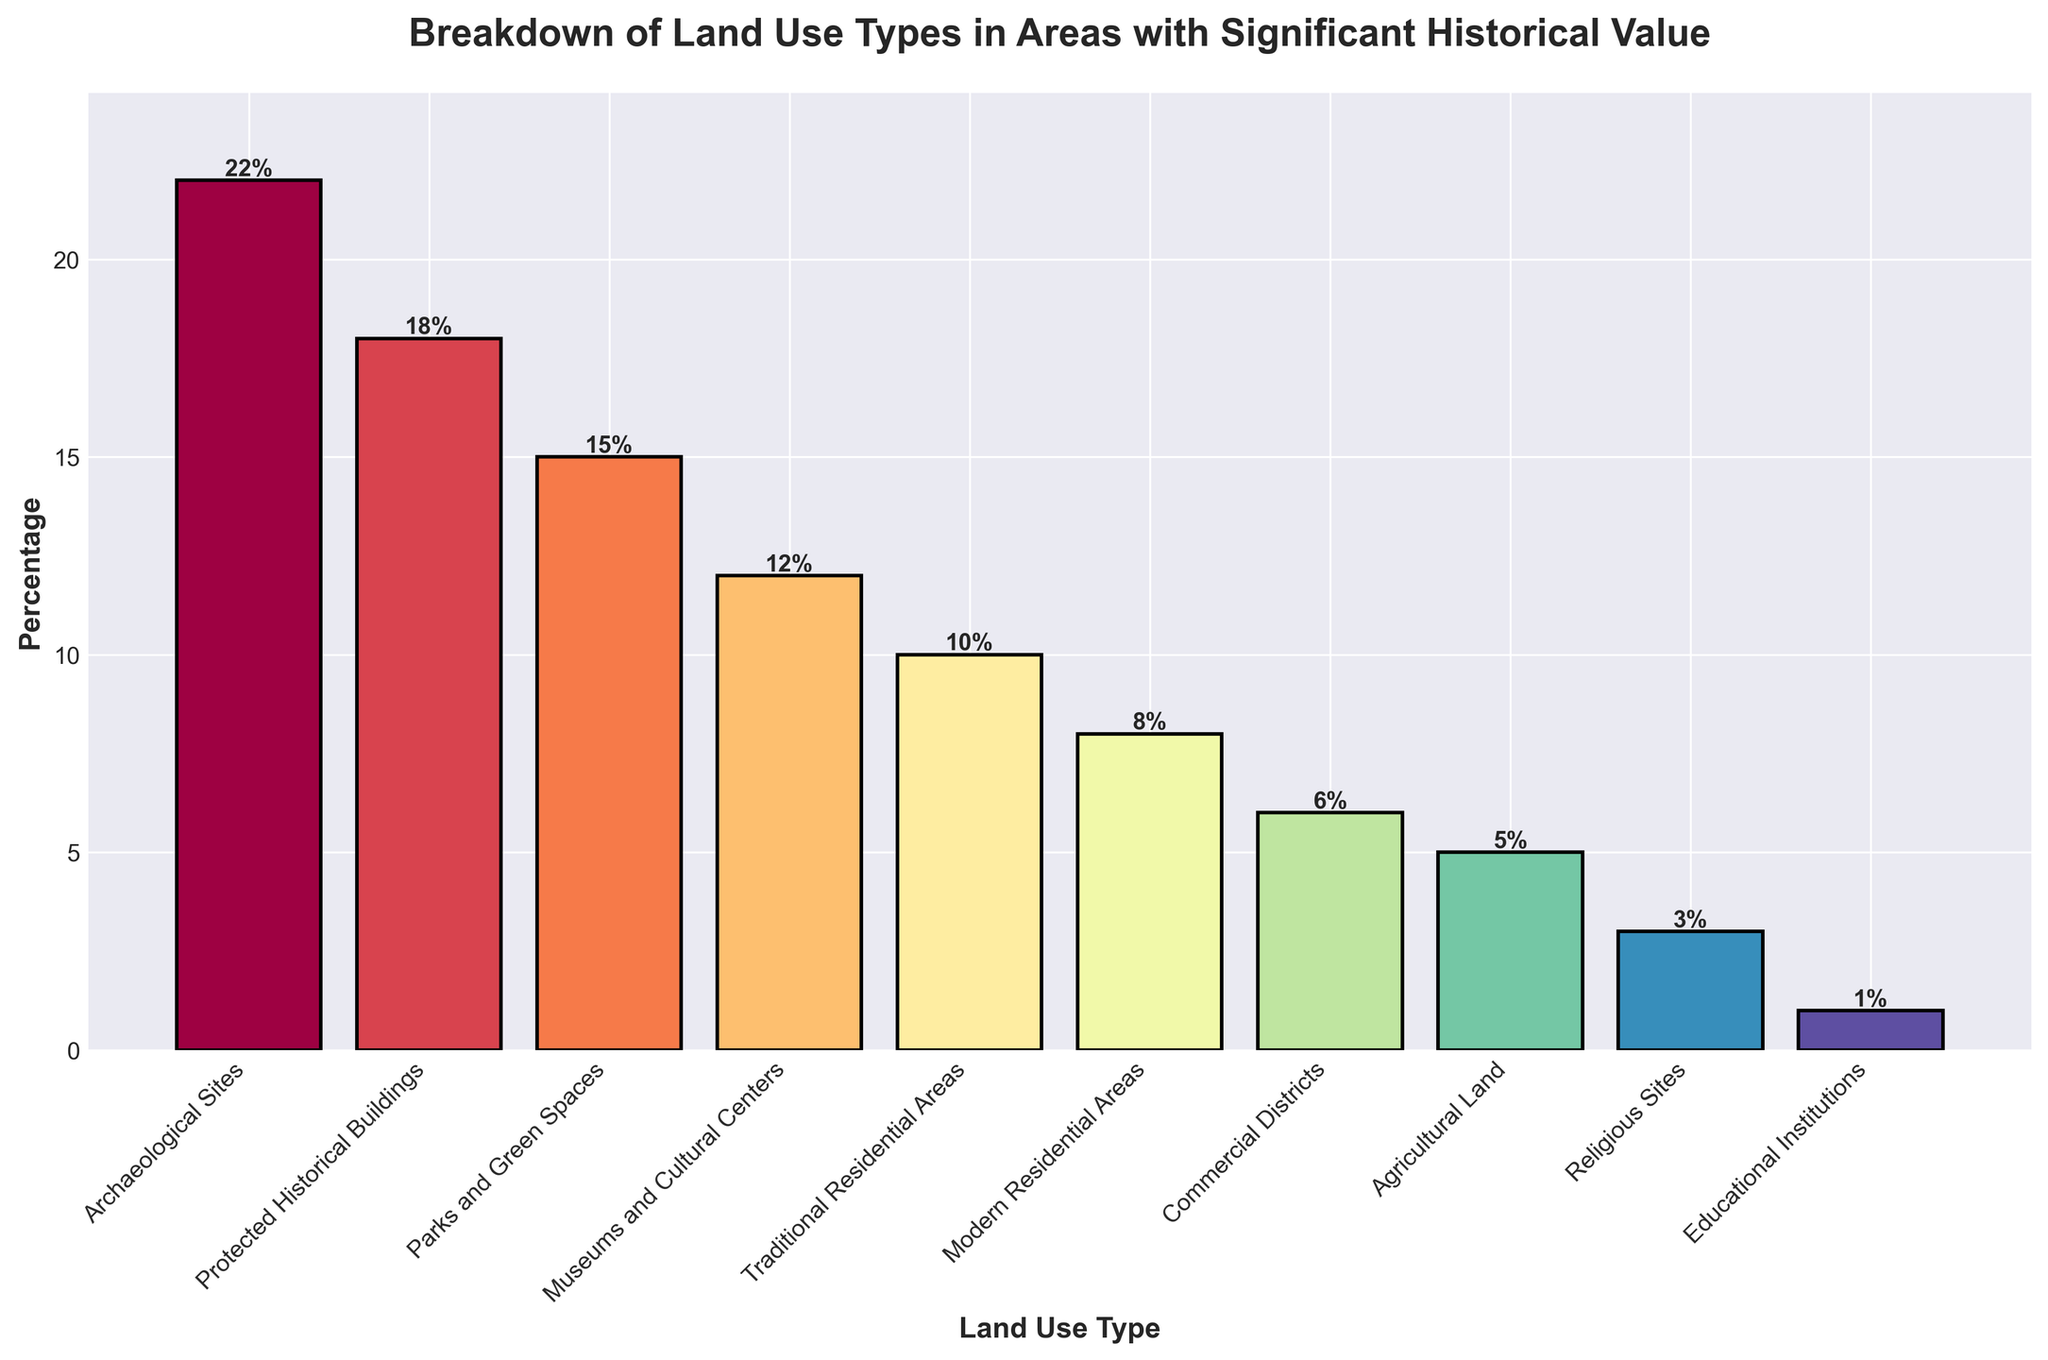what percentage of land use types are residential (traditional and modern) combined? The percentage for traditional residential areas is 10% and for modern residential areas is 8%. Adding these together gives 10% + 8% = 18%
Answer: 18% Which land use type has the highest percentage? Observing the height of the bars, the "Archaeological Sites" has the tallest bar indicating the highest percentage at 22%
Answer: Archaeological Sites How do the percentages of parks and green spaces compare to agricultural land? The percentage of parks and green spaces is 15%, whereas agricultural land is 5%. The difference is 15% - 5% = 10%
Answer: Parks and green spaces are 10% higher What is the visual difference between the number of religious sites and educational institutions? The bar for religious sites is larger than the bar for educational institutions. This indicates visually that religious sites (3%) are more common than educational institutions (1%) by 2%
Answer: Religious sites are 2% higher Can you find a land use type that has a percentage greater than commercial districts but less than modern residential areas? Modern residential areas have 8% and commercial districts have 6%. "Traditional Residential Areas" has a percentage of 10%, which falls between these ranges
Answer: Traditional Residential Areas What is the total percentage of land use types represented in cultural and recreational categories (museums and cultural centers, parks and green spaces)? Museums and cultural centers have 12% and parks and green spaces have 15%. Adding these gives 12% + 15% = 27%
Answer: 27% Which two land use types have the same visual color hue? The question involves recognizing that each bar is colored differently. Since each category has a distinct color, no two land use types share the same color hue
Answer: None have the same color hue If the land used for educational institutions increased by 3%, which land use types will have the same percentage? The current percentage for educational institutions is 1%; if it increased by 3%, it would be 1% + 3% = 4%. This new percentage would not match any other current land use categories
Answer: None will match Between protected historical buildings and museums and cultural centers, which is closer in percentage to agricultural land? Protected historical buildings have 18%, museums and cultural centers have 12%, and agricultural land has 5%. The difference is
Answer: Protected historical buildings are 13% higher; museums and cultural centers are 7% higher What percentage do commercial districts and religious sites combined make up? Commercial districts account for 6% and religious sites account for 3%. Adding these together gives 6% + 3% = 9%
Answer: 9% 